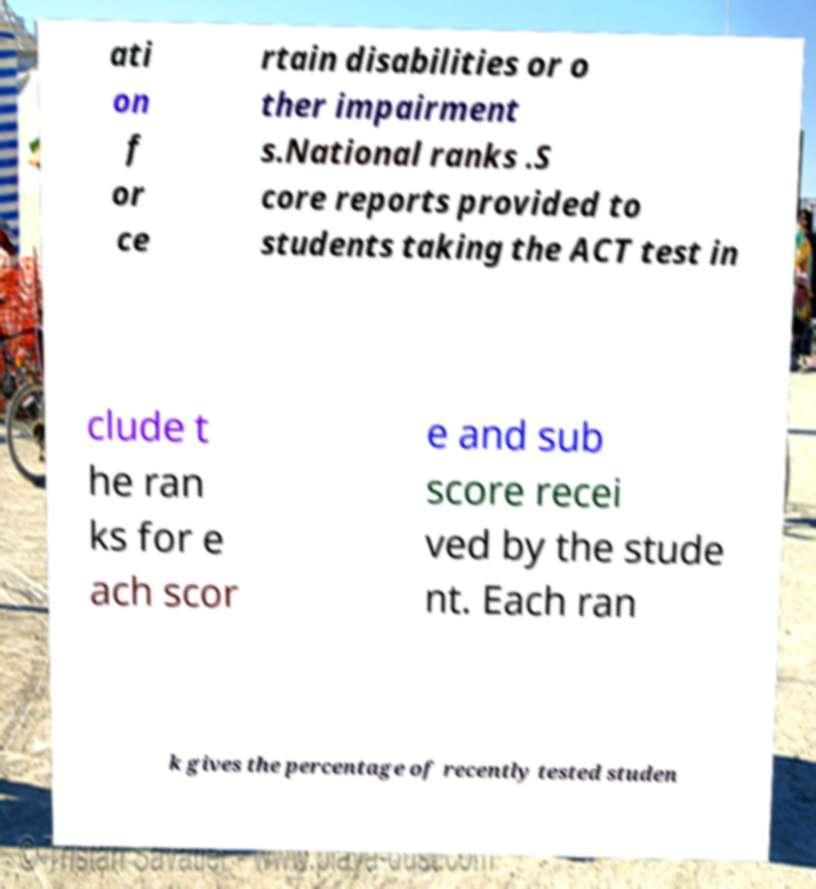Could you assist in decoding the text presented in this image and type it out clearly? ati on f or ce rtain disabilities or o ther impairment s.National ranks .S core reports provided to students taking the ACT test in clude t he ran ks for e ach scor e and sub score recei ved by the stude nt. Each ran k gives the percentage of recently tested studen 